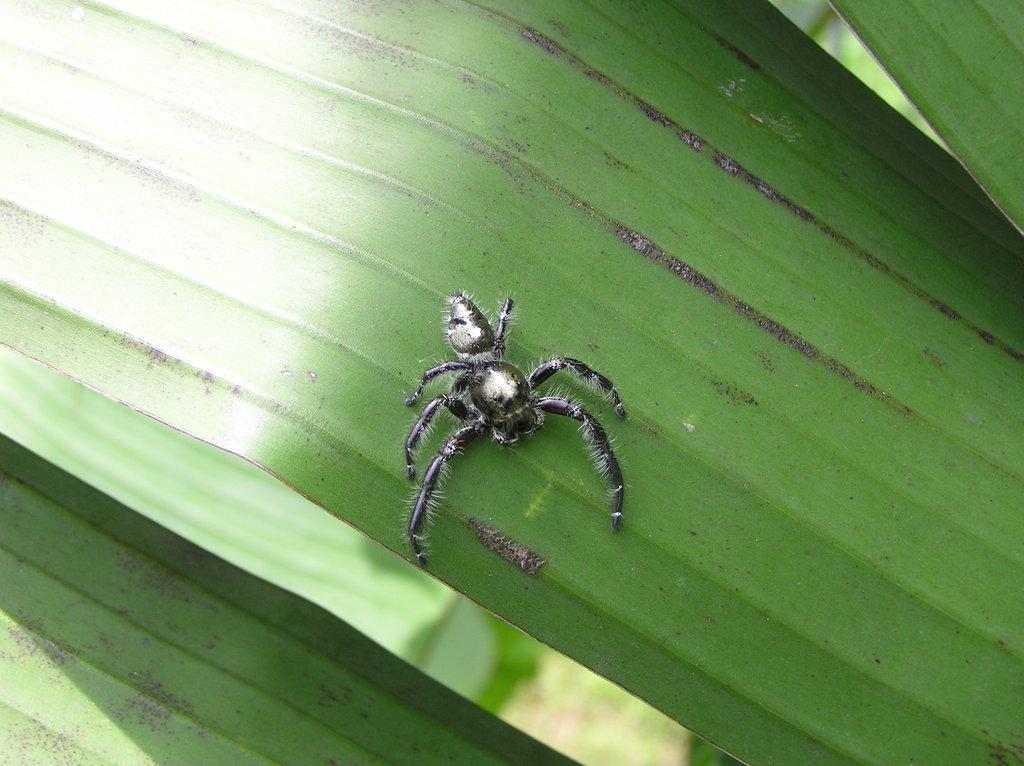What is present on the leaf in the image? There is an insect on the leaf in the image. Can you describe the insect's location on the leaf? The insect is on the leaf in the image. What type of songs can be heard coming from the insect in the image? There is no indication in the image that the insect is producing any sounds, so it's not possible to determine what, if any, songs might be heard. 